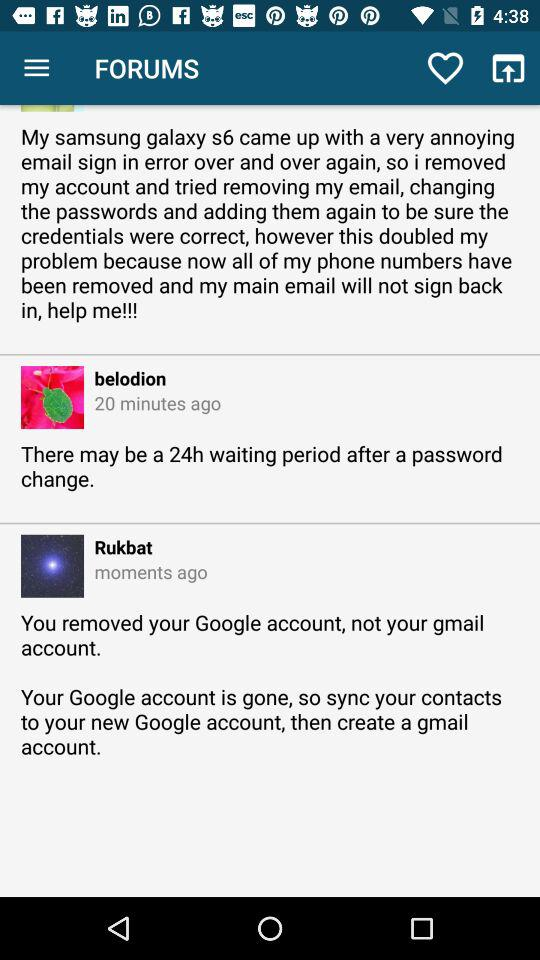When did "belodion" comment? "belodion" commented 20 minutes ago. 